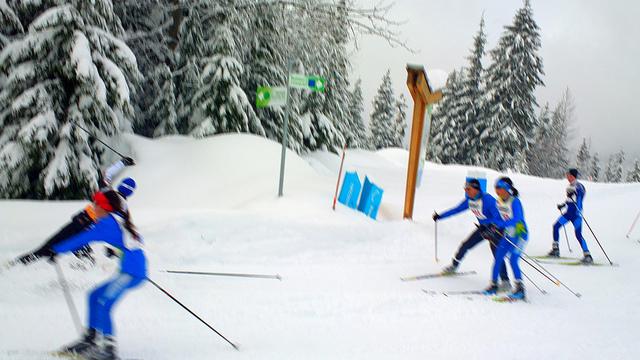How many skiers are in this photo?
Answer briefly. 5. Is the snow on the trees melting?
Short answer required. No. Are these skier's competing?
Concise answer only. Yes. 